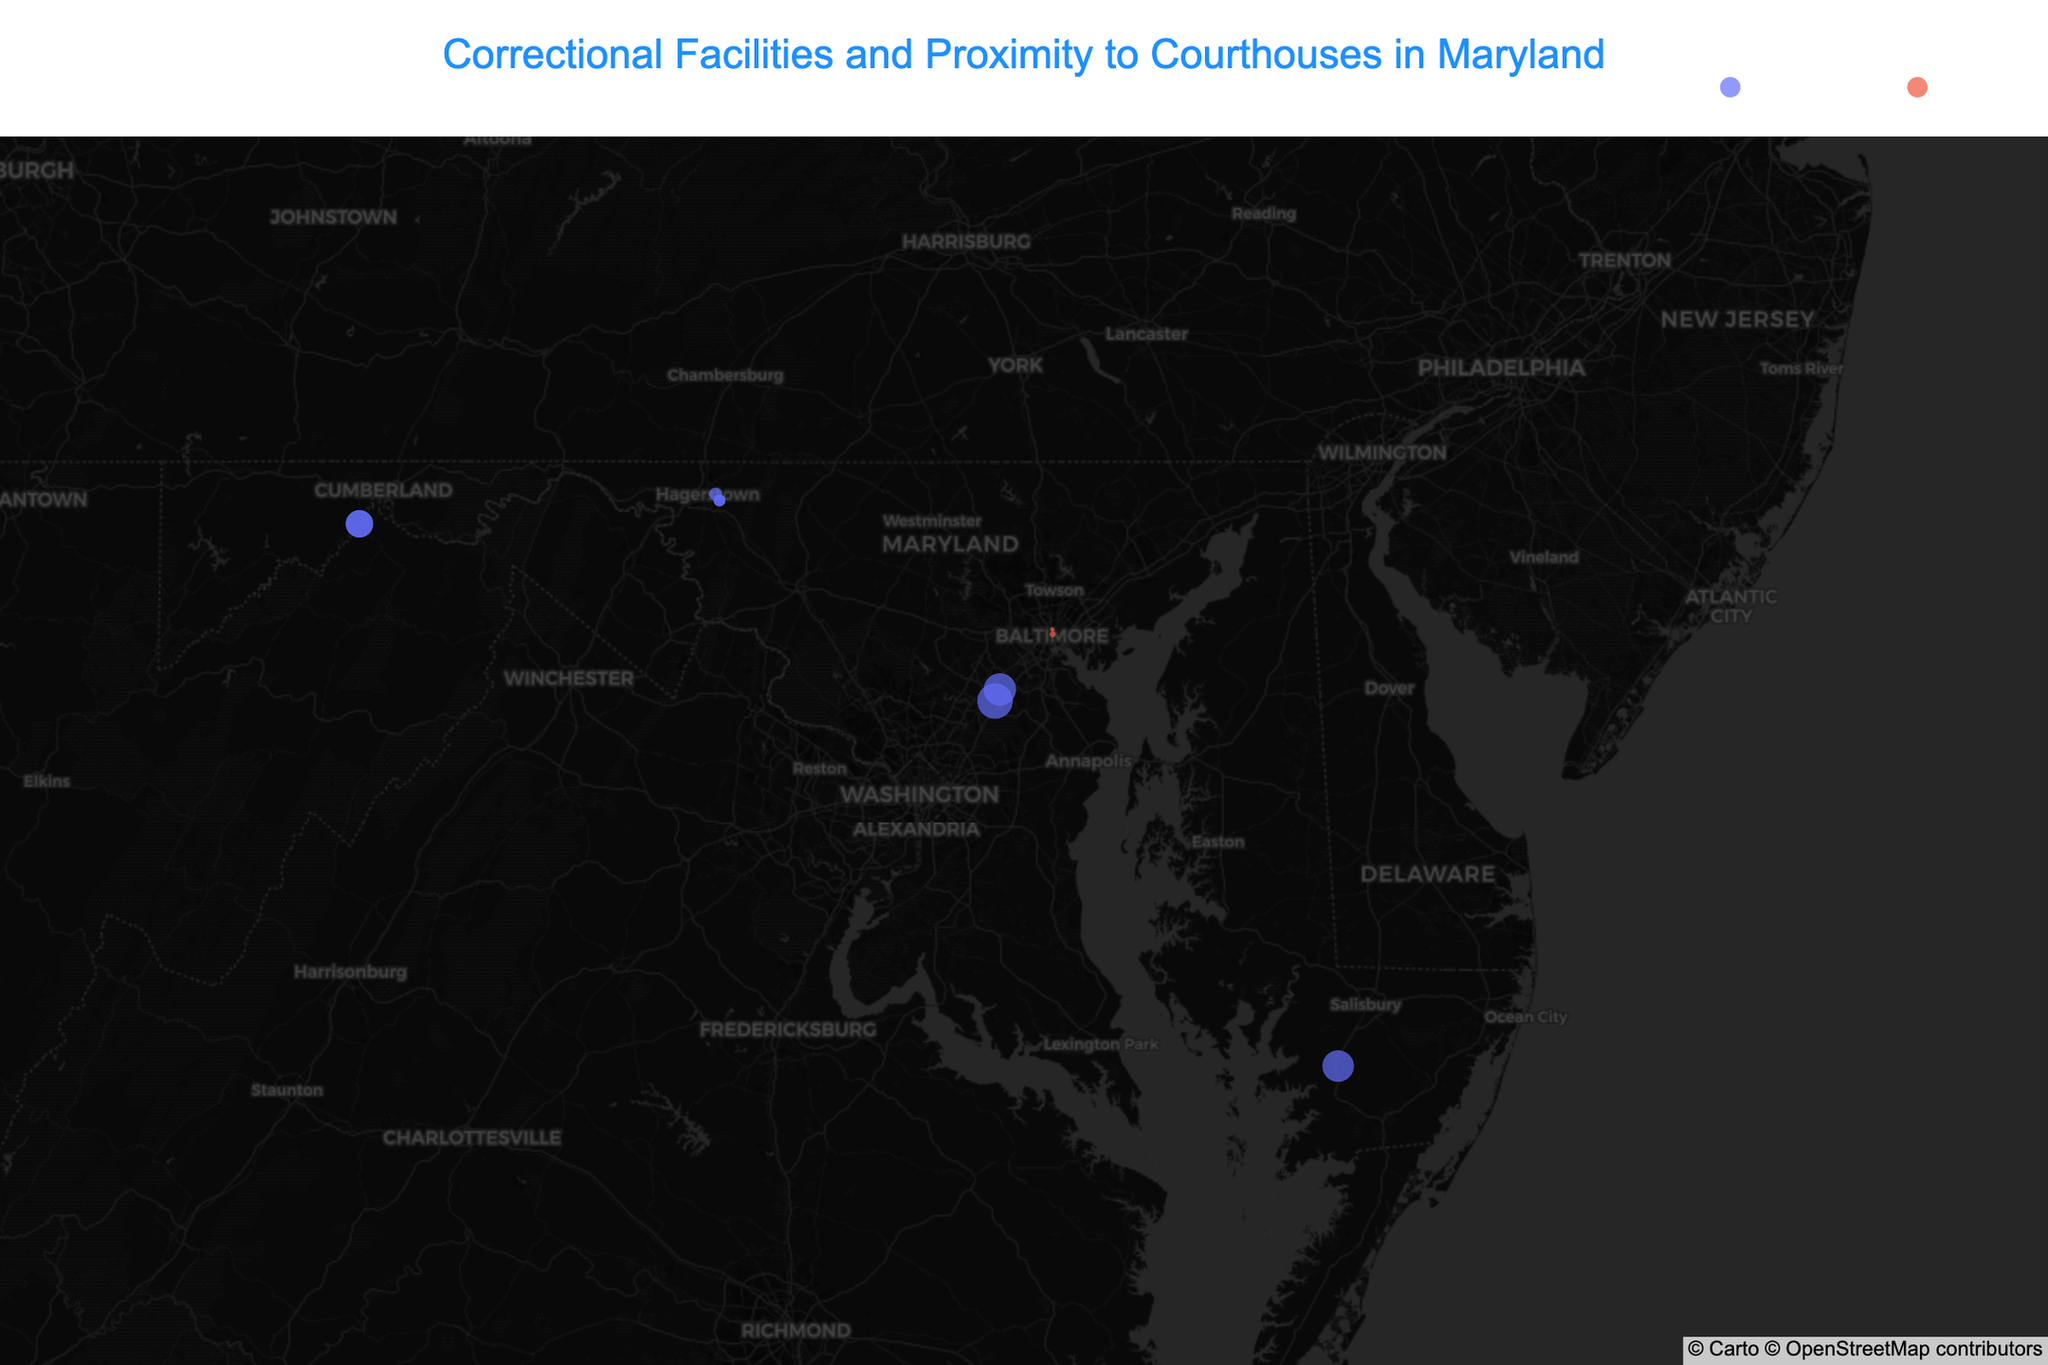What's the title of the figure? The title of the figure is written at the top of the plot.
Answer: Correctional Facilities and Proximity to Courthouses in Maryland How many correctional facilities are displayed in the figure? By counting the number of unique facility names for 'Correctional' type in the hover labels, we get the total number of correctional facilities. There are 7 unique correctional facilities listed: Maryland Correctional Institution - Jessup, Eastern Correctional Institution, Maryland Correctional Institution - Hagerstown, Patuxent Institution, Western Correctional Institution, North Branch Correctional Institution, Roxbury Correctional Institution, and Maryland Correctional Training Center.
Answer: 8 Which facility is farthest from its nearest courthouse? The hover information provides the distance to the nearest courthouse for each facility. The Patuxent Institution, with a distance of 14.6 miles to the Howard County District Court, is the farthest.
Answer: Patuxent Institution What is the average distance to the nearest courthouse for all facilities? To calculate the average distance, sum up all the distances to the nearest courthouse and divide by the number of facilities. The values are 12.3, 0.5, 0.3, 11.7, 2.1, 14.6, 8.9, 8.9, 1.8, and 1.8 miles respectively. Sum = 63.9 and there are 10 facilities. So, the average distance is 63.9 / 10 = 6.39 miles.
Answer: 6.4 miles Which facility is closest to its nearest courthouse, and how close is it? From the hover information, Chesapeake Detention Facility is closest to Baltimore City District Court with a distance of 0.3 miles.
Answer: Chesapeake Detention Facility, 0.3 miles Are there any facilities with the same distance to their nearest courthouse? By examining the distance values in the hover information, North Branch Correctional Institution and Western Correctional Institution both have a distance of 8.9 miles to their nearest courthouses.
Answer: Yes In which county is the Maryland Correctional Institution - Jessup located close to its nearest courthouse? By looking at the hover information for the Maryland Correctional Institution - Jessup, its nearest courthouse is Howard County Circuit Court. Therefore, it is close to Howard County.
Answer: Howard County Which type of facility is more prevalent in the figure, correctional or detention? Observing the number of points colored by type: there are more 'Correctional' facilities than 'Detention' facilities. Specifically, there are 8 Correctional facilities and 2 Detention facilities.
Answer: Correctional Which courthouse is nearest to the most facilities? By examining the hover information for each facility to identify the courthouses, Washington County Circuit Court appears twice (for Maryland Correctional Training Center and Maryland Correctional Institution - Hagerstown).
Answer: Washington County Circuit Court 